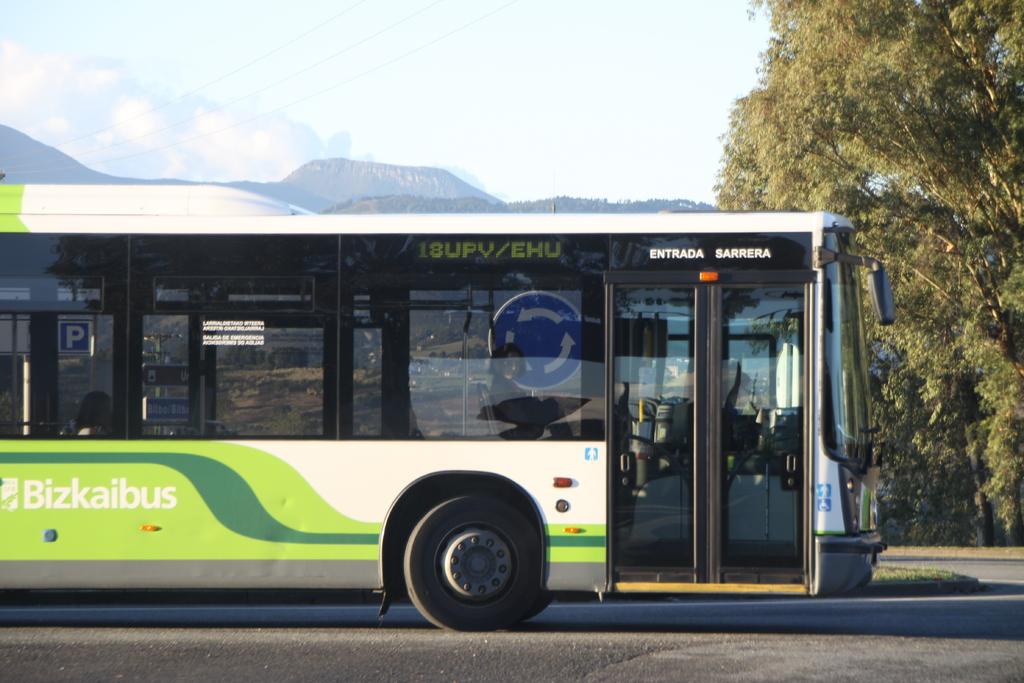Where is the bus going?
Your answer should be very brief. 18upv/ehu. What is the name of the bus?
Your response must be concise. Bizkaibus. 